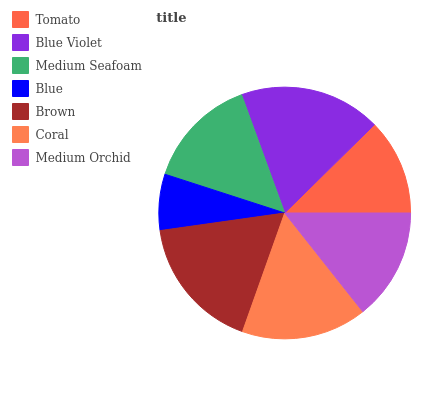Is Blue the minimum?
Answer yes or no. Yes. Is Blue Violet the maximum?
Answer yes or no. Yes. Is Medium Seafoam the minimum?
Answer yes or no. No. Is Medium Seafoam the maximum?
Answer yes or no. No. Is Blue Violet greater than Medium Seafoam?
Answer yes or no. Yes. Is Medium Seafoam less than Blue Violet?
Answer yes or no. Yes. Is Medium Seafoam greater than Blue Violet?
Answer yes or no. No. Is Blue Violet less than Medium Seafoam?
Answer yes or no. No. Is Medium Seafoam the high median?
Answer yes or no. Yes. Is Medium Seafoam the low median?
Answer yes or no. Yes. Is Tomato the high median?
Answer yes or no. No. Is Blue Violet the low median?
Answer yes or no. No. 